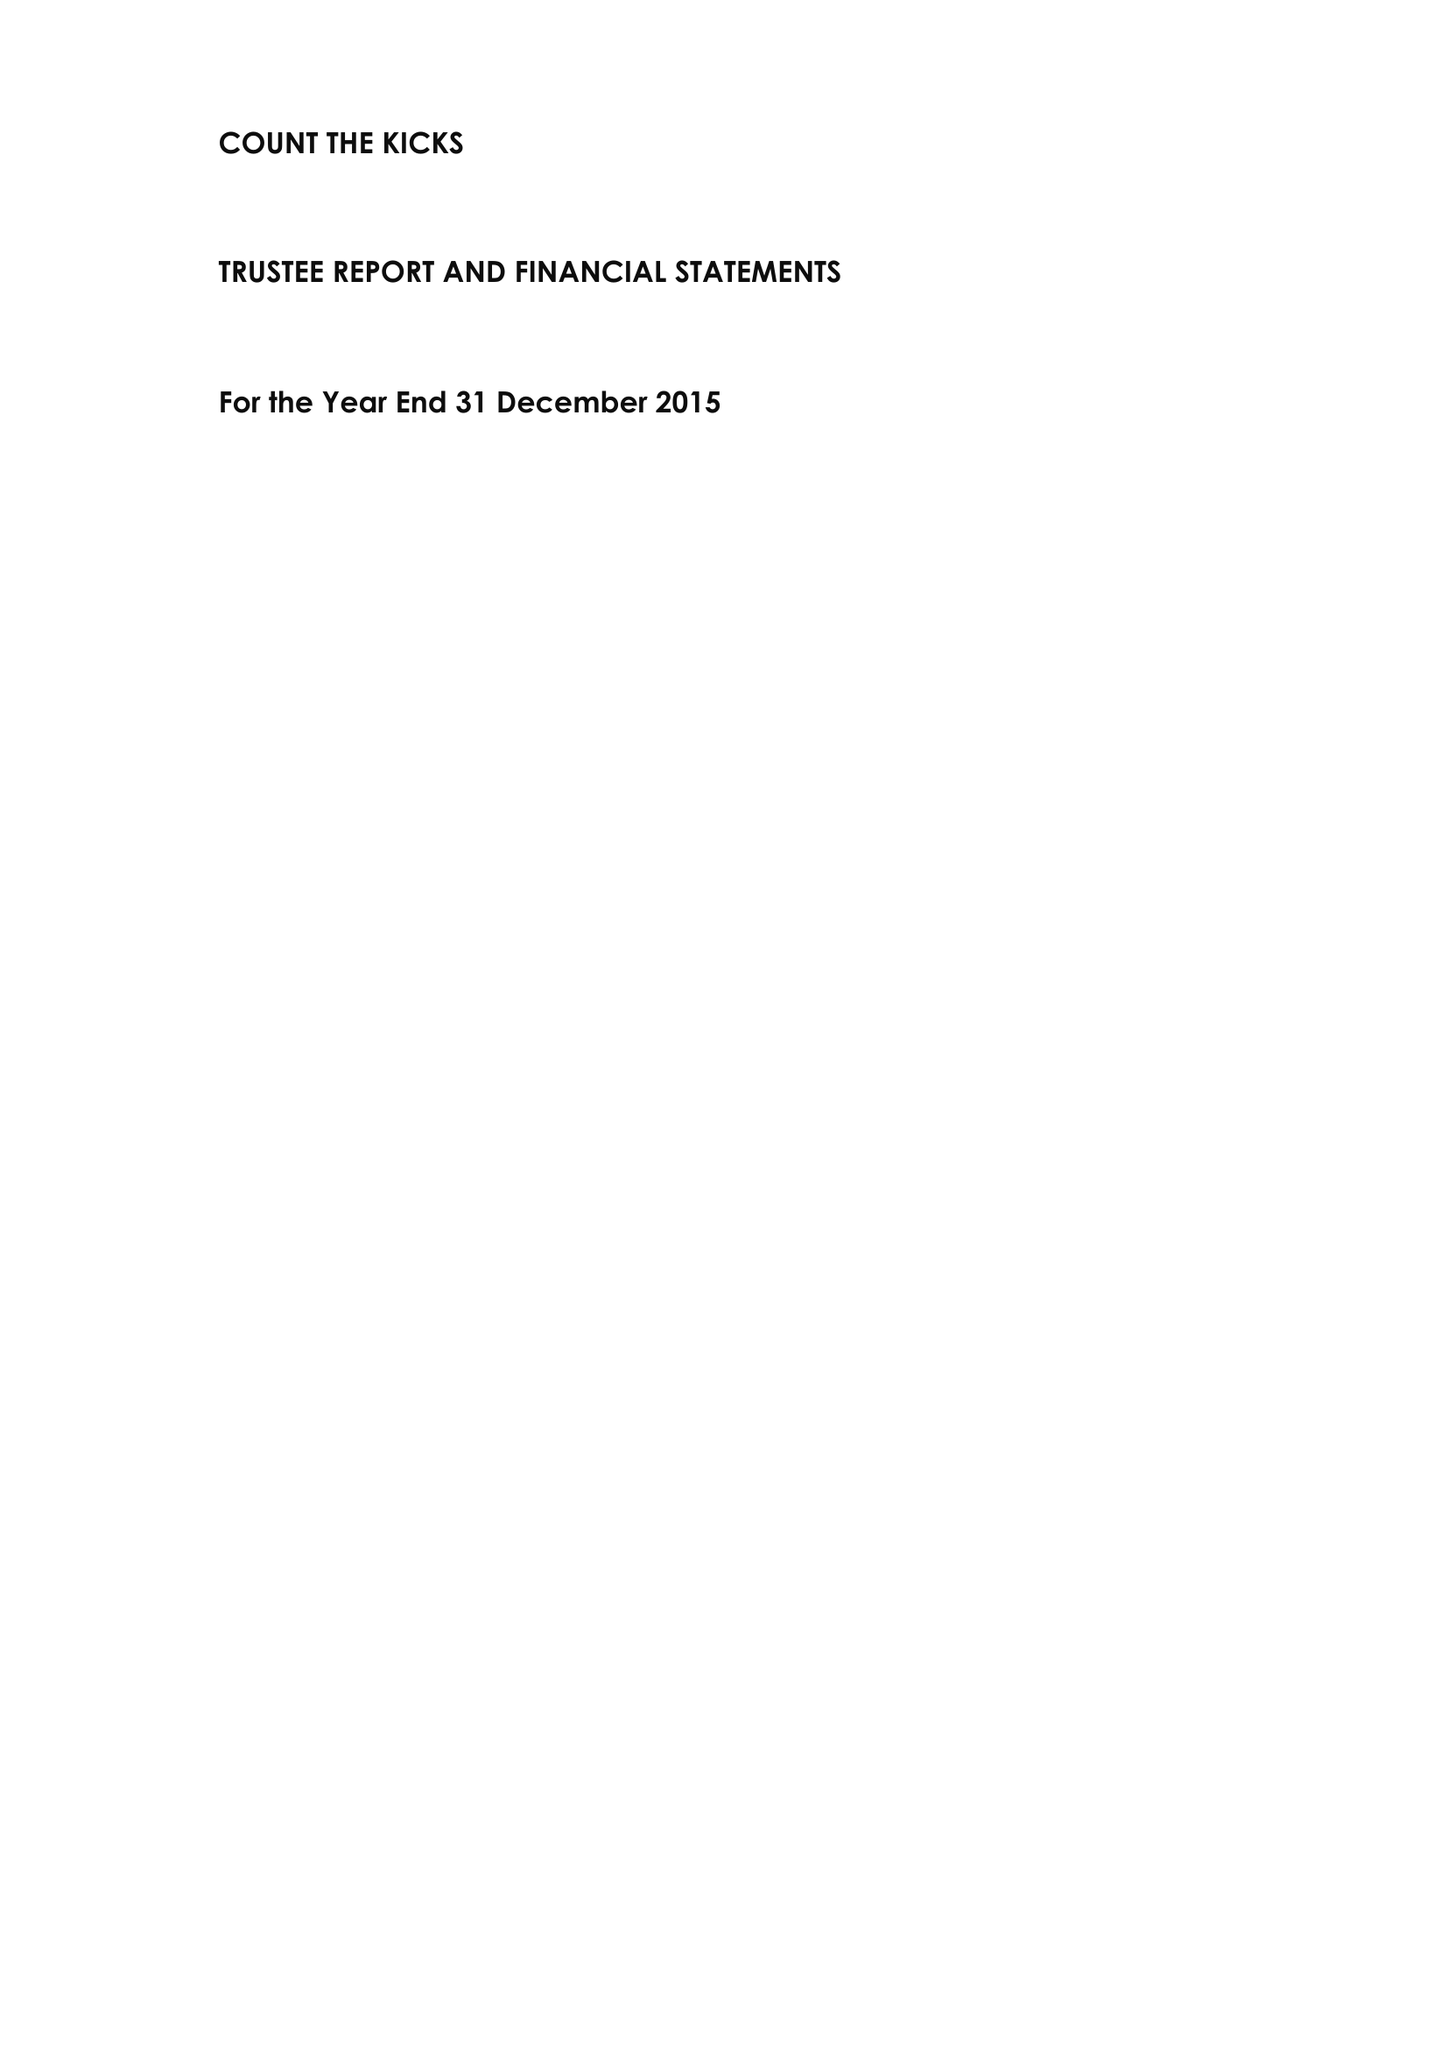What is the value for the address__street_line?
Answer the question using a single word or phrase. 10 THE COPSE 